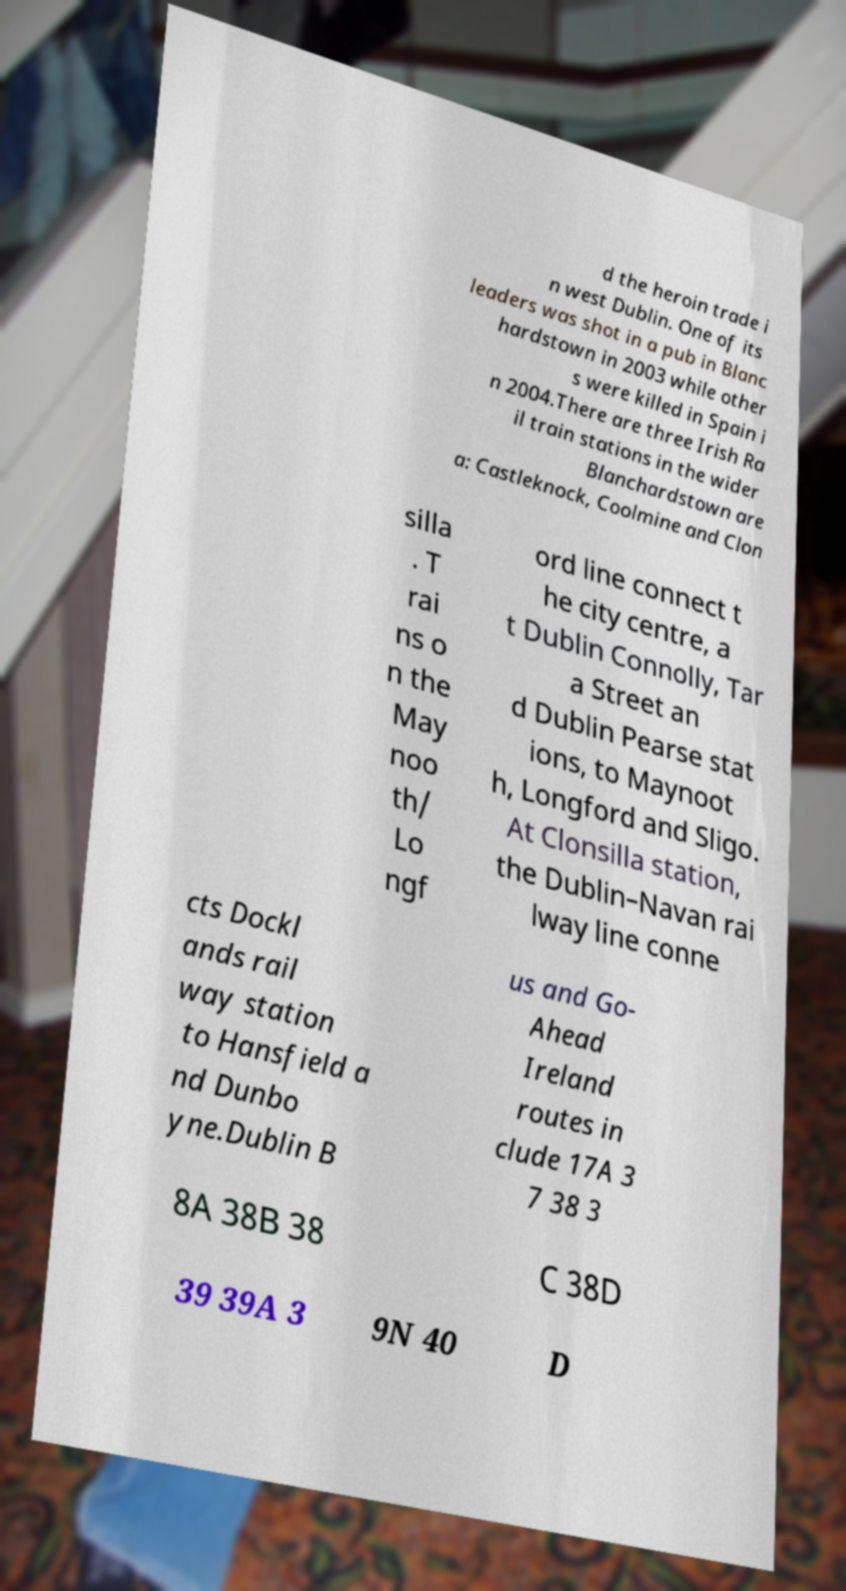Could you extract and type out the text from this image? d the heroin trade i n west Dublin. One of its leaders was shot in a pub in Blanc hardstown in 2003 while other s were killed in Spain i n 2004.There are three Irish Ra il train stations in the wider Blanchardstown are a: Castleknock, Coolmine and Clon silla . T rai ns o n the May noo th/ Lo ngf ord line connect t he city centre, a t Dublin Connolly, Tar a Street an d Dublin Pearse stat ions, to Maynoot h, Longford and Sligo. At Clonsilla station, the Dublin–Navan rai lway line conne cts Dockl ands rail way station to Hansfield a nd Dunbo yne.Dublin B us and Go- Ahead Ireland routes in clude 17A 3 7 38 3 8A 38B 38 C 38D 39 39A 3 9N 40 D 